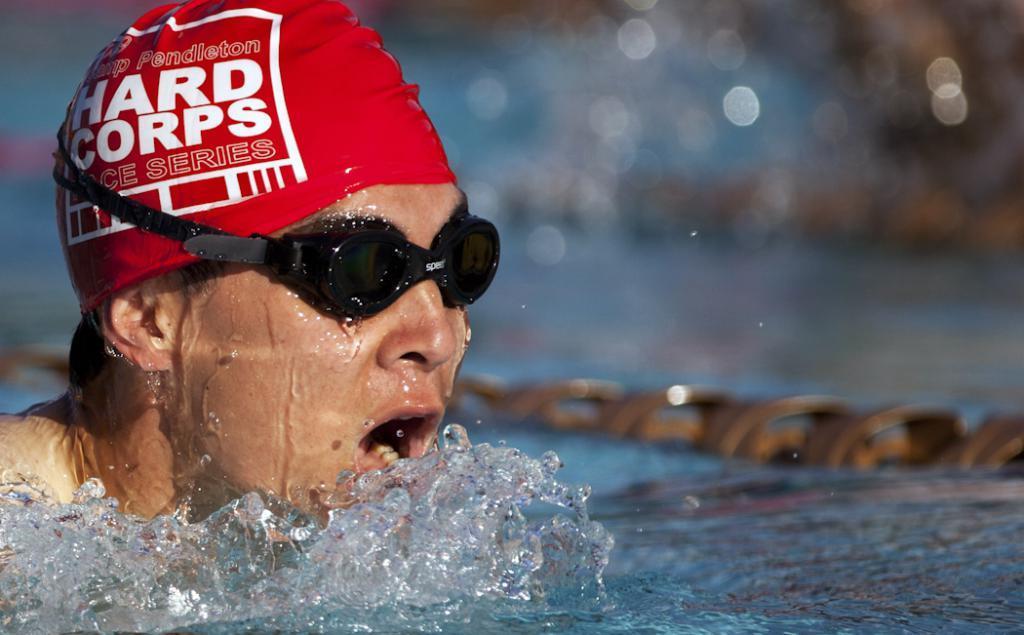Describe this image in one or two sentences. In this picture we can see a person in the water, and the person wore spectacles. 